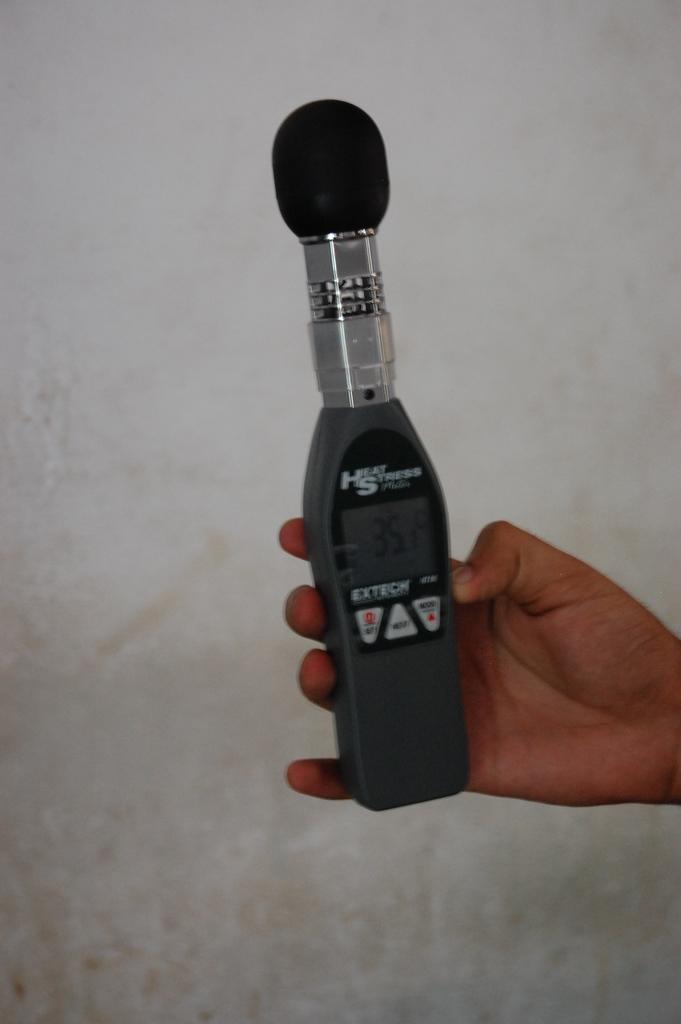What is the main subject of the image? There is a person in the image. What is the person holding in their hand? The person is holding an object in their hand. What can be observed about the background of the image? The background of the image is completely white. What type of hill can be seen in the background of the image? There is no hill present in the image, as the background is completely white. 